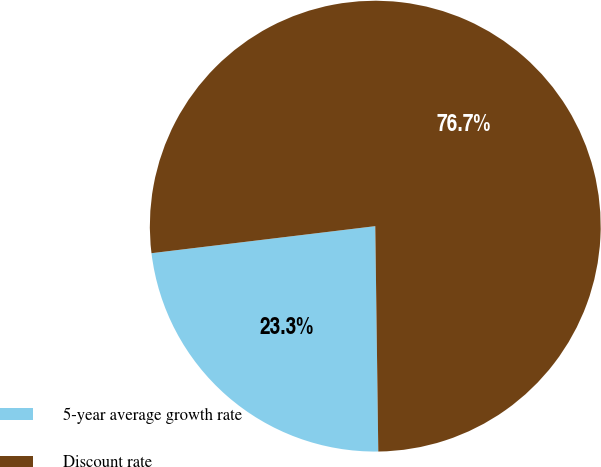Convert chart. <chart><loc_0><loc_0><loc_500><loc_500><pie_chart><fcel>5-year average growth rate<fcel>Discount rate<nl><fcel>23.3%<fcel>76.7%<nl></chart> 